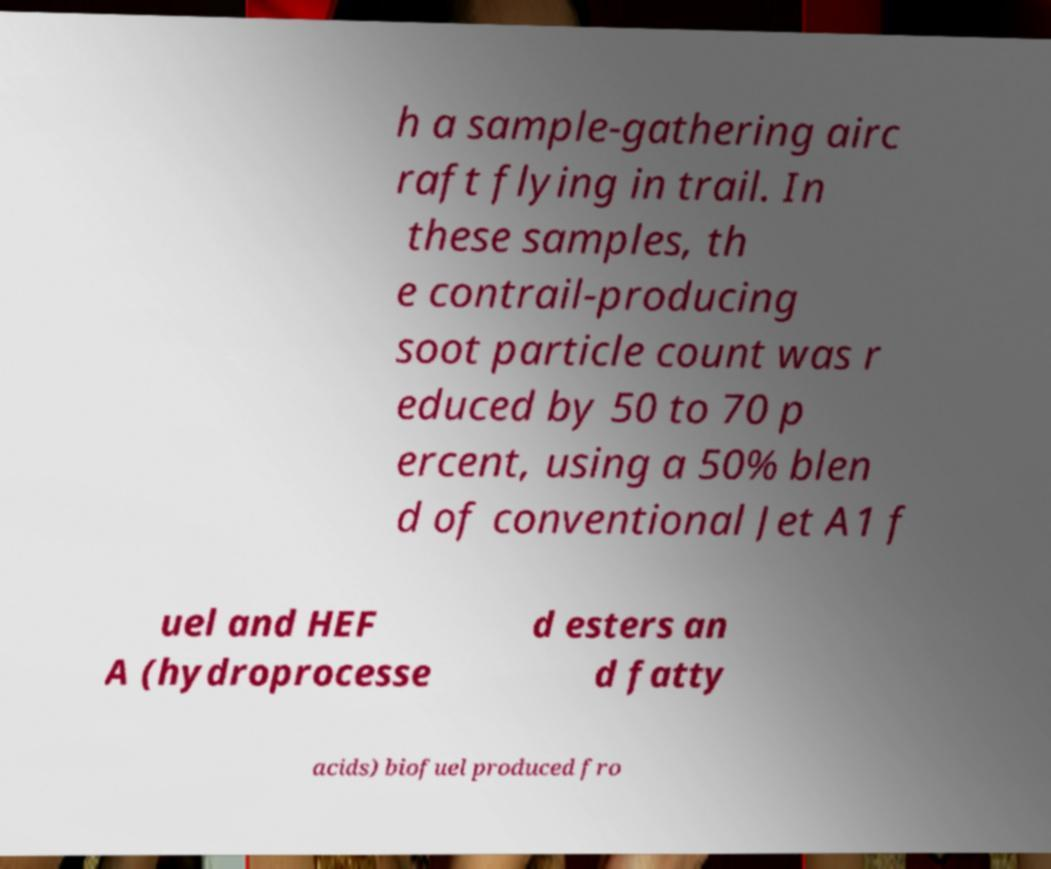Can you accurately transcribe the text from the provided image for me? h a sample-gathering airc raft flying in trail. In these samples, th e contrail-producing soot particle count was r educed by 50 to 70 p ercent, using a 50% blen d of conventional Jet A1 f uel and HEF A (hydroprocesse d esters an d fatty acids) biofuel produced fro 